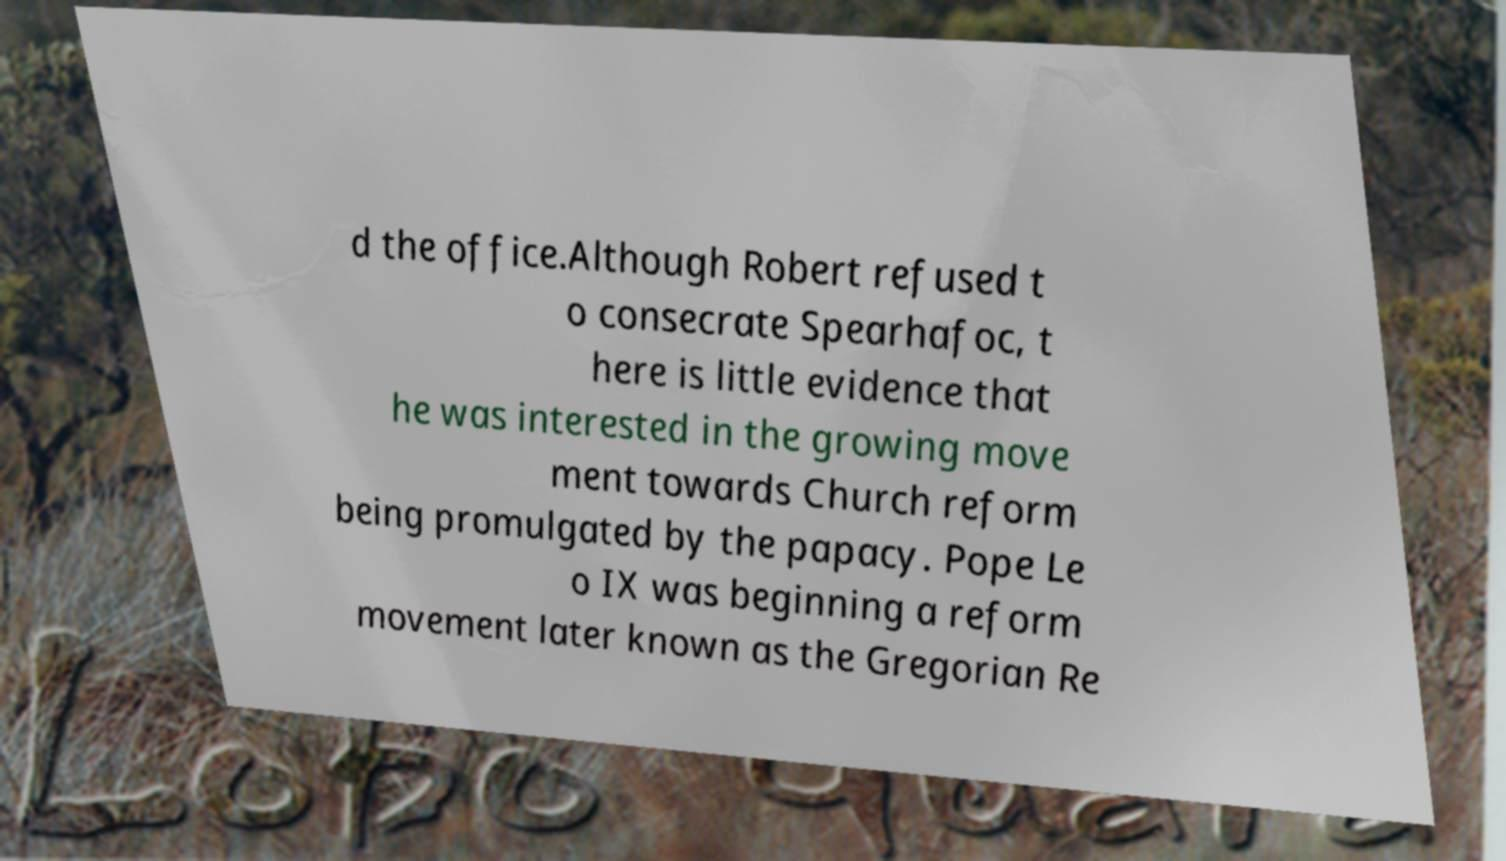Could you assist in decoding the text presented in this image and type it out clearly? d the office.Although Robert refused t o consecrate Spearhafoc, t here is little evidence that he was interested in the growing move ment towards Church reform being promulgated by the papacy. Pope Le o IX was beginning a reform movement later known as the Gregorian Re 